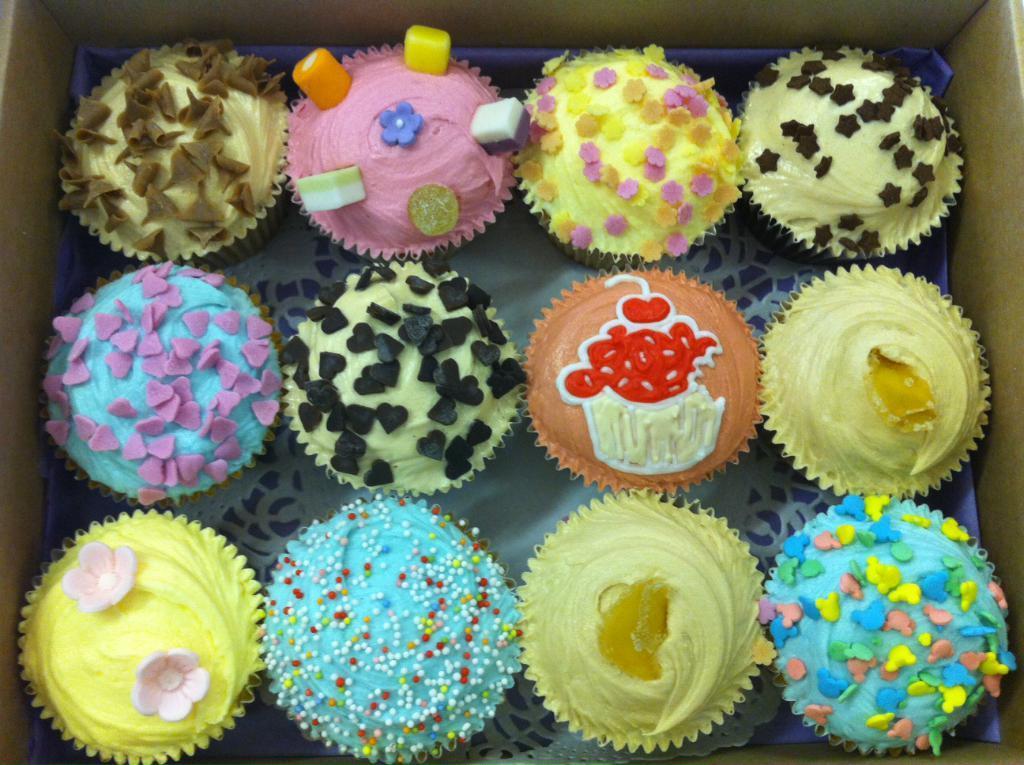Could you give a brief overview of what you see in this image? In this picture there are cupcakes of different varieties. The cupcakes are in a box. 